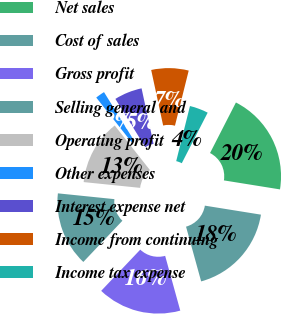Convert chart. <chart><loc_0><loc_0><loc_500><loc_500><pie_chart><fcel>Net sales<fcel>Cost of sales<fcel>Gross profit<fcel>Selling general and<fcel>Operating profit<fcel>Other expenses<fcel>Interest expense net<fcel>Income from continuing<fcel>Income tax expense<nl><fcel>20.0%<fcel>18.18%<fcel>16.36%<fcel>14.55%<fcel>12.73%<fcel>1.82%<fcel>5.45%<fcel>7.27%<fcel>3.64%<nl></chart> 